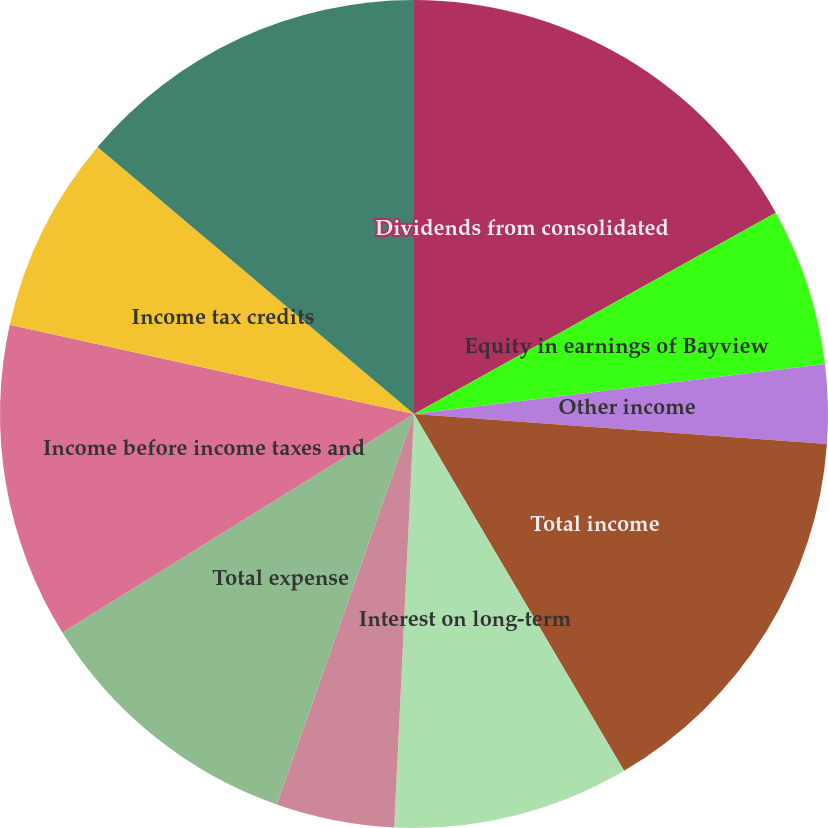<chart> <loc_0><loc_0><loc_500><loc_500><pie_chart><fcel>Dividends from consolidated<fcel>Equity in earnings of Bayview<fcel>Other income<fcel>Total income<fcel>Interest on long-term<fcel>Other expense<fcel>Total expense<fcel>Income before income taxes and<fcel>Income tax credits<fcel>Income before equity in<nl><fcel>16.92%<fcel>6.15%<fcel>3.08%<fcel>15.38%<fcel>9.23%<fcel>4.62%<fcel>10.77%<fcel>12.31%<fcel>7.69%<fcel>13.85%<nl></chart> 